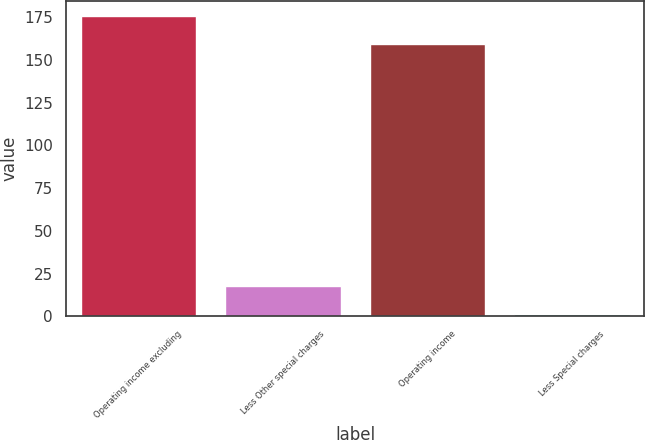Convert chart to OTSL. <chart><loc_0><loc_0><loc_500><loc_500><bar_chart><fcel>Operating income excluding<fcel>Less Other special charges<fcel>Operating income<fcel>Less Special charges<nl><fcel>175.87<fcel>17.97<fcel>159.4<fcel>1.5<nl></chart> 